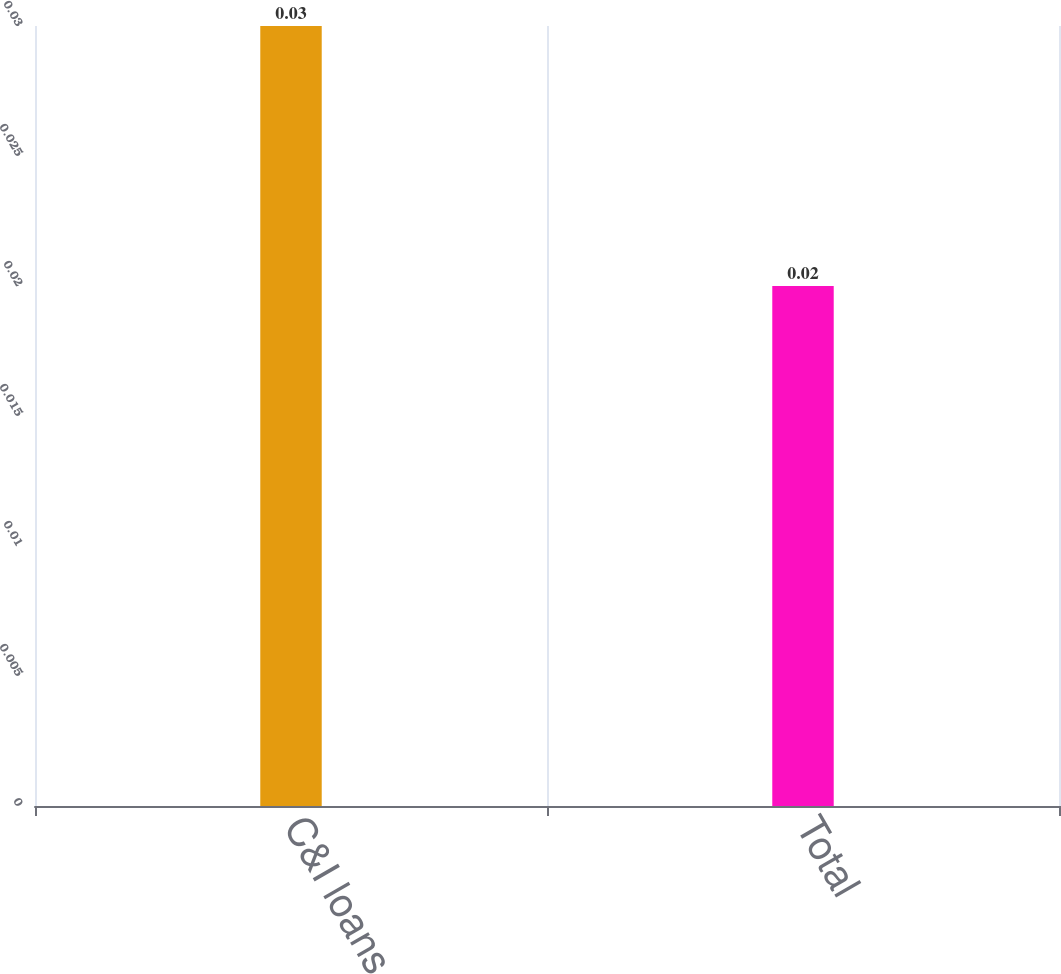Convert chart. <chart><loc_0><loc_0><loc_500><loc_500><bar_chart><fcel>C&I loans<fcel>Total<nl><fcel>0.03<fcel>0.02<nl></chart> 